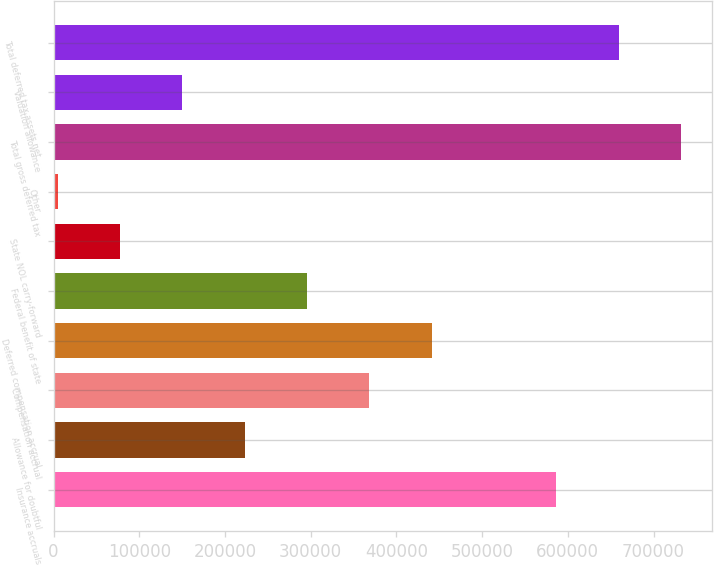<chart> <loc_0><loc_0><loc_500><loc_500><bar_chart><fcel>Insurance accruals<fcel>Allowance for doubtful<fcel>Compensation accrual<fcel>Deferred compensation accrual<fcel>Federal benefit of state<fcel>State NOL carry-forward<fcel>Other<fcel>Total gross deferred tax<fcel>Valuation allowance<fcel>Total deferred tax assets net<nl><fcel>586402<fcel>222792<fcel>368236<fcel>440958<fcel>295514<fcel>77348<fcel>4626<fcel>731846<fcel>150070<fcel>659124<nl></chart> 